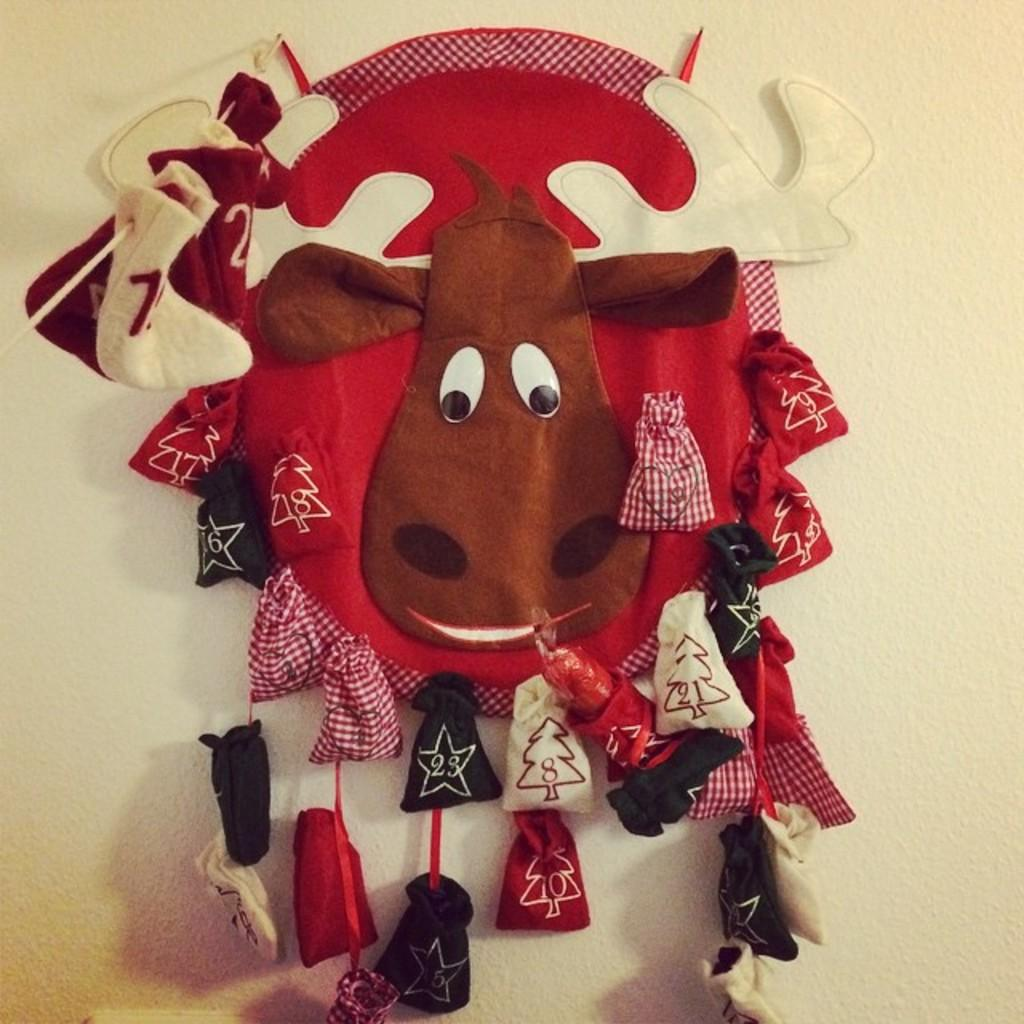What is present on the wall in the image? There are clothes on the wall in the image. Can you describe the clothes on the wall? Unfortunately, the image does not provide enough detail to describe the clothes. What might be the purpose of hanging clothes on the wall? The clothes could be on display, drying, or being stored. What type of hair can be seen on the wall in the image? There is no hair visible on the wall in the image. What sense is being stimulated by the clothes on the wall in the image? The image does not provide enough information to determine which sense might be stimulated by the clothes on the wall. 